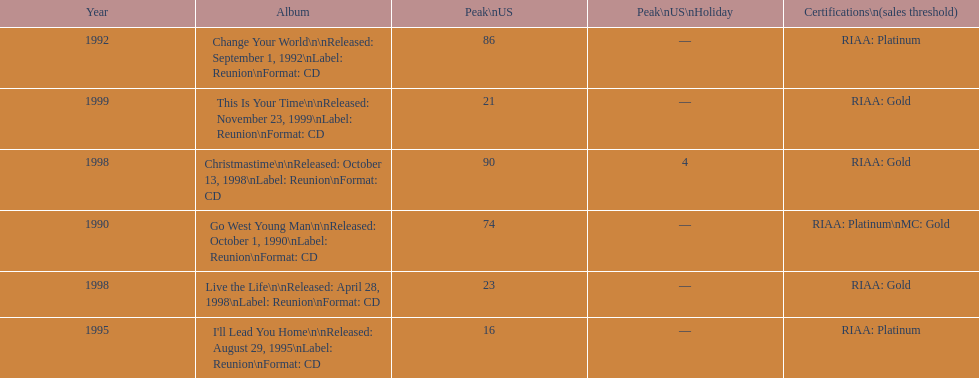How many album entries are there? 6. 